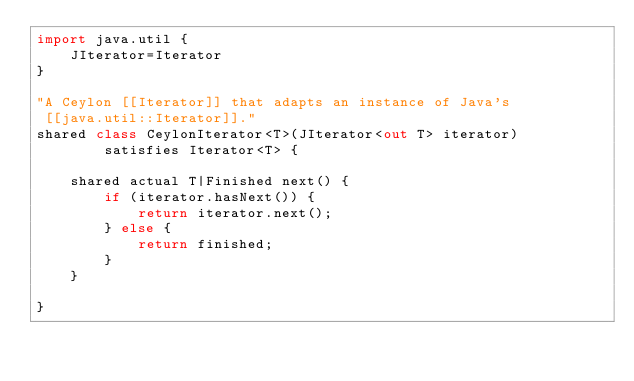<code> <loc_0><loc_0><loc_500><loc_500><_Ceylon_>import java.util {
    JIterator=Iterator
}

"A Ceylon [[Iterator]] that adapts an instance of Java's 
 [[java.util::Iterator]]."
shared class CeylonIterator<T>(JIterator<out T> iterator) 
        satisfies Iterator<T> {

    shared actual T|Finished next() {
        if (iterator.hasNext()) {
            return iterator.next();
        } else {
            return finished;
        }
    }
    
}
</code> 